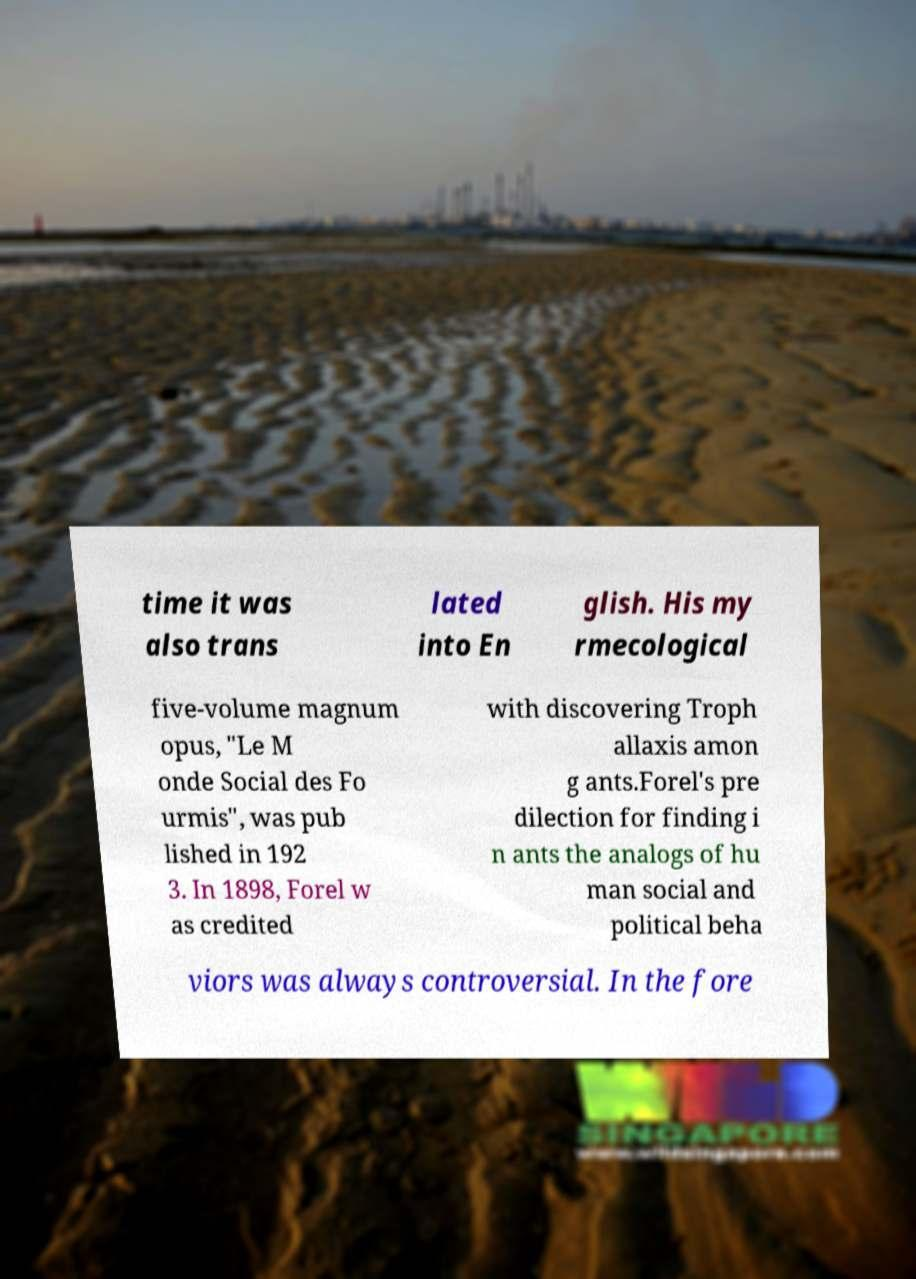What messages or text are displayed in this image? I need them in a readable, typed format. time it was also trans lated into En glish. His my rmecological five-volume magnum opus, "Le M onde Social des Fo urmis", was pub lished in 192 3. In 1898, Forel w as credited with discovering Troph allaxis amon g ants.Forel's pre dilection for finding i n ants the analogs of hu man social and political beha viors was always controversial. In the fore 